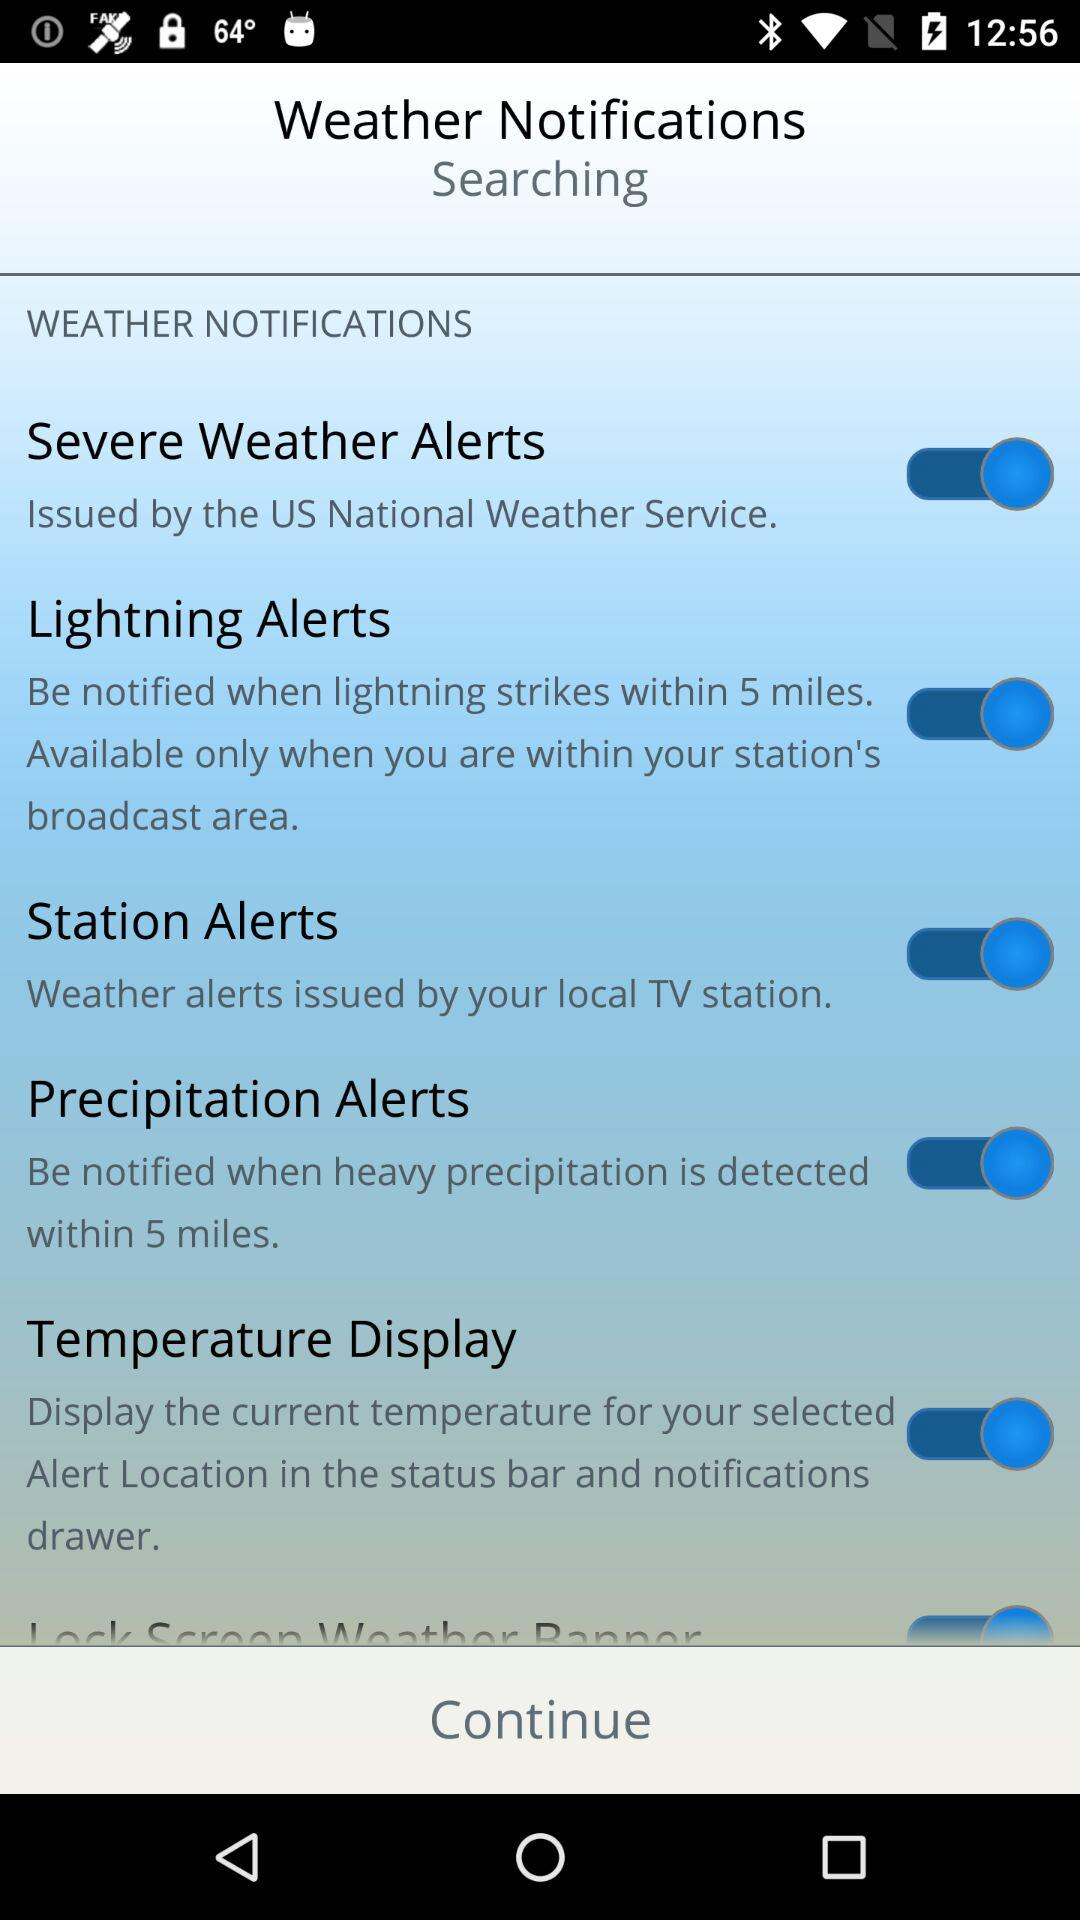What is the status of "Lightning Alerts"? The status is "on". 